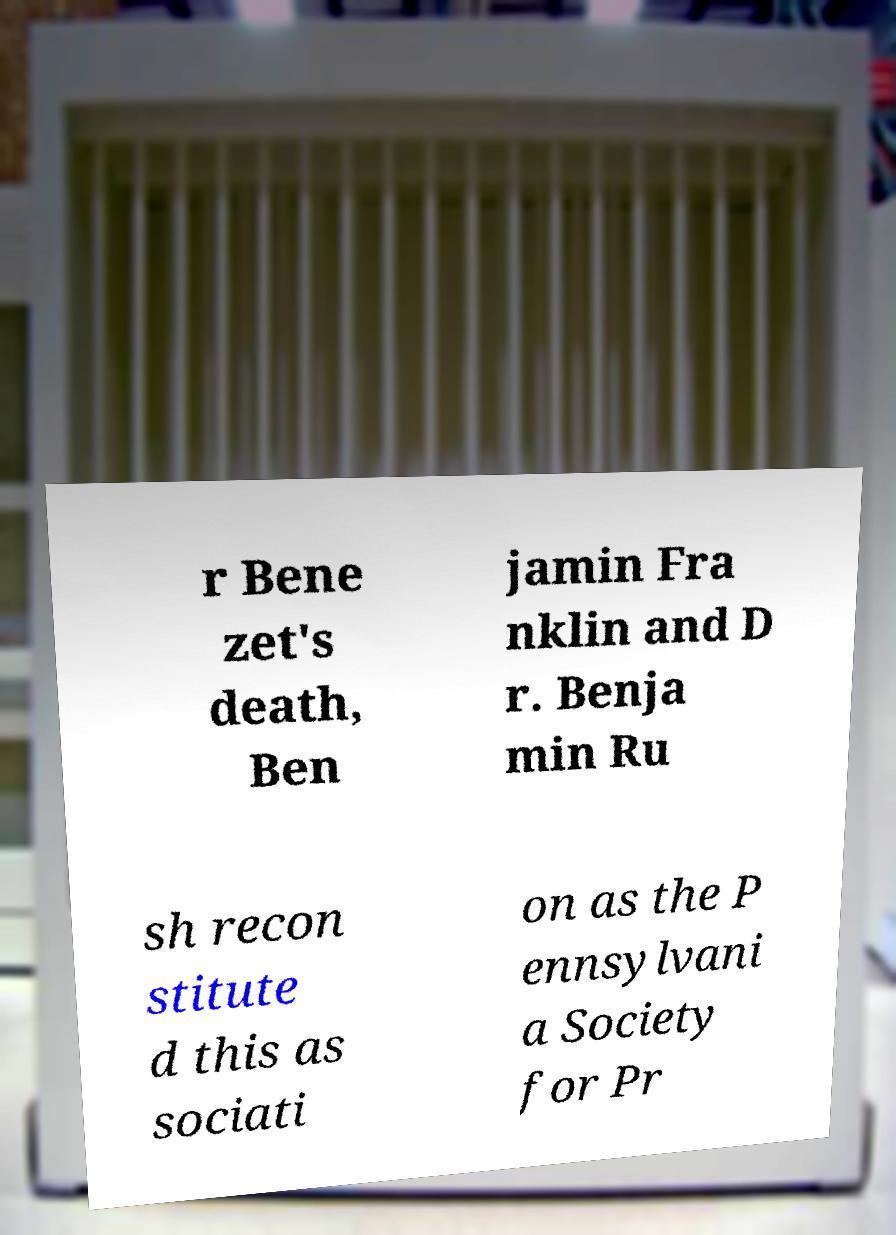Please read and relay the text visible in this image. What does it say? r Bene zet's death, Ben jamin Fra nklin and D r. Benja min Ru sh recon stitute d this as sociati on as the P ennsylvani a Society for Pr 